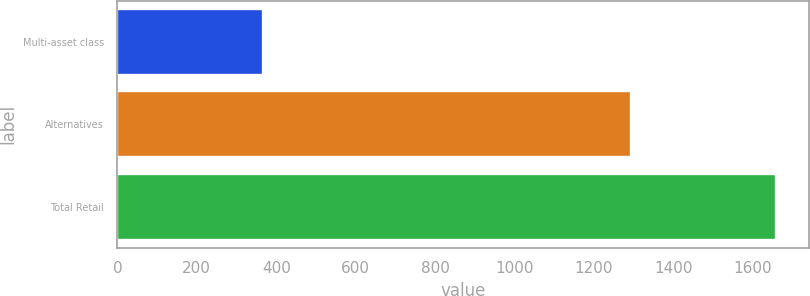Convert chart to OTSL. <chart><loc_0><loc_0><loc_500><loc_500><bar_chart><fcel>Multi-asset class<fcel>Alternatives<fcel>Total Retail<nl><fcel>366<fcel>1293<fcel>1659<nl></chart> 